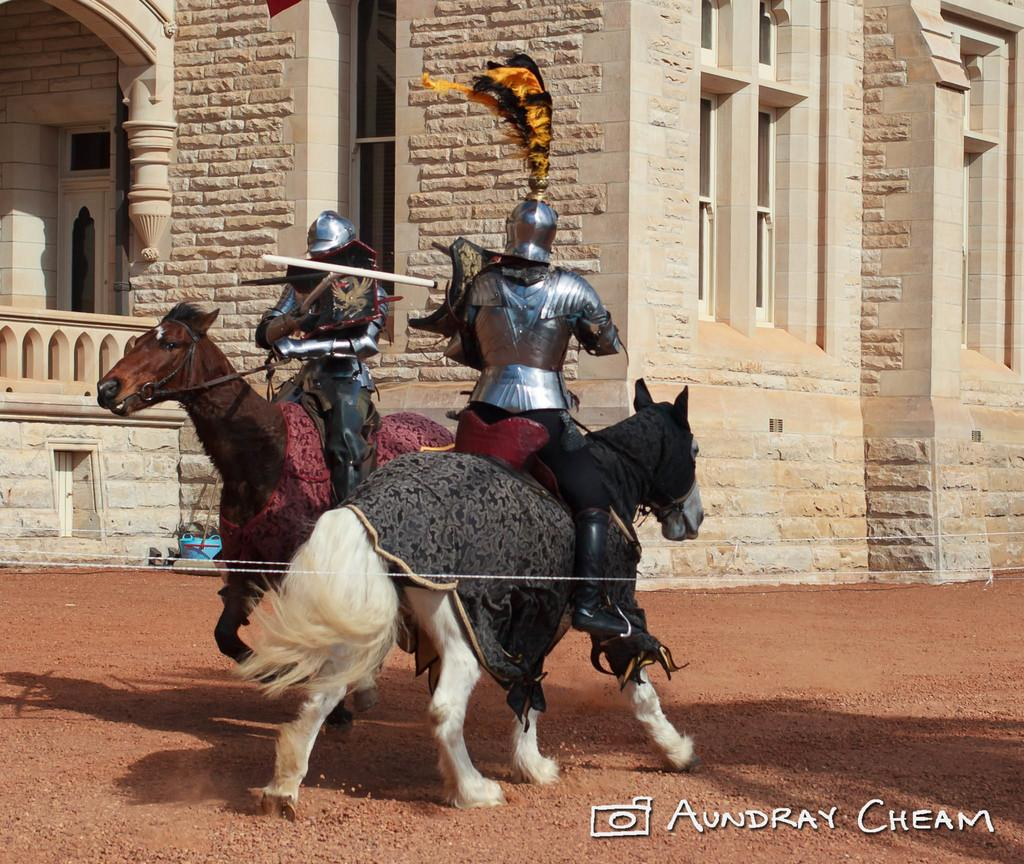What is happening in the image involving the horse? There are people sitting on a horse in the image. What are the people holding while sitting on the horse? The people are holding a stick. What can be seen in the distance behind the horse and people? There is a building in the background of the image. Can you describe the blue object in the background? There is a blue color object in the background of the image. What type of brush is the uncle using to groom the beast in the image? There is no uncle, brush, or beast present in the image. 